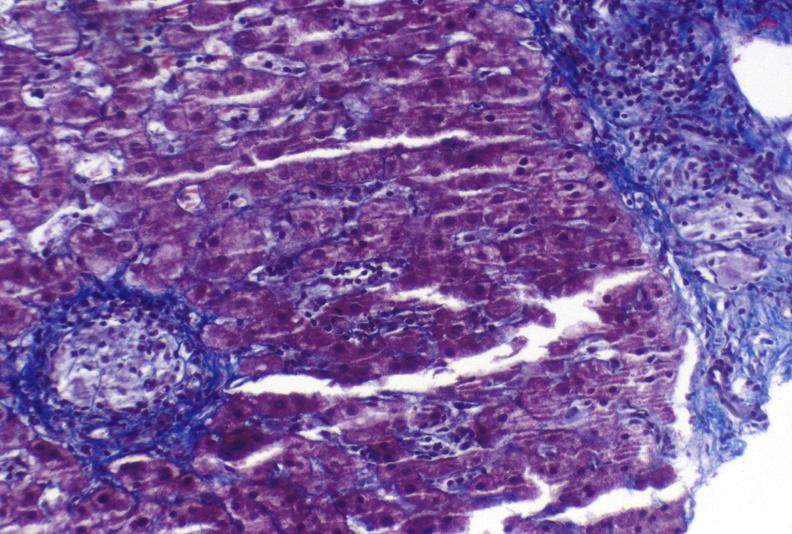what is present?
Answer the question using a single word or phrase. Hepatobiliary 